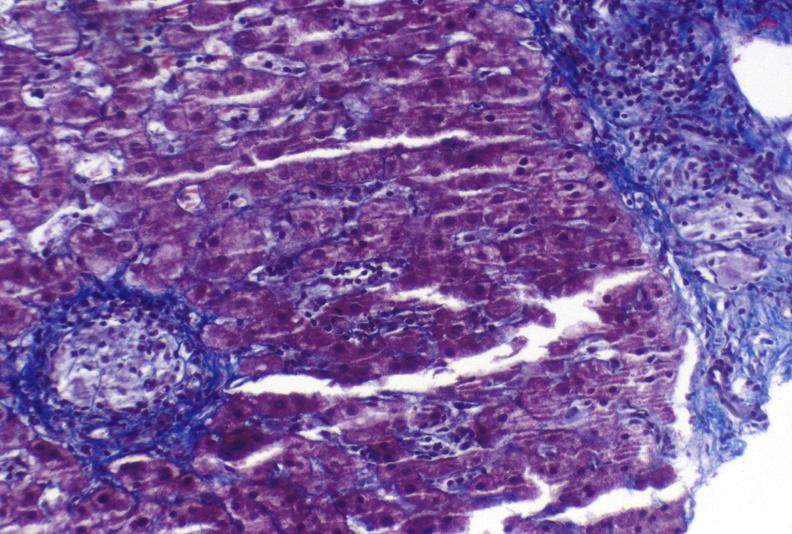what is present?
Answer the question using a single word or phrase. Hepatobiliary 